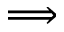Convert formula to latex. <formula><loc_0><loc_0><loc_500><loc_500>\Longrightarrow</formula> 